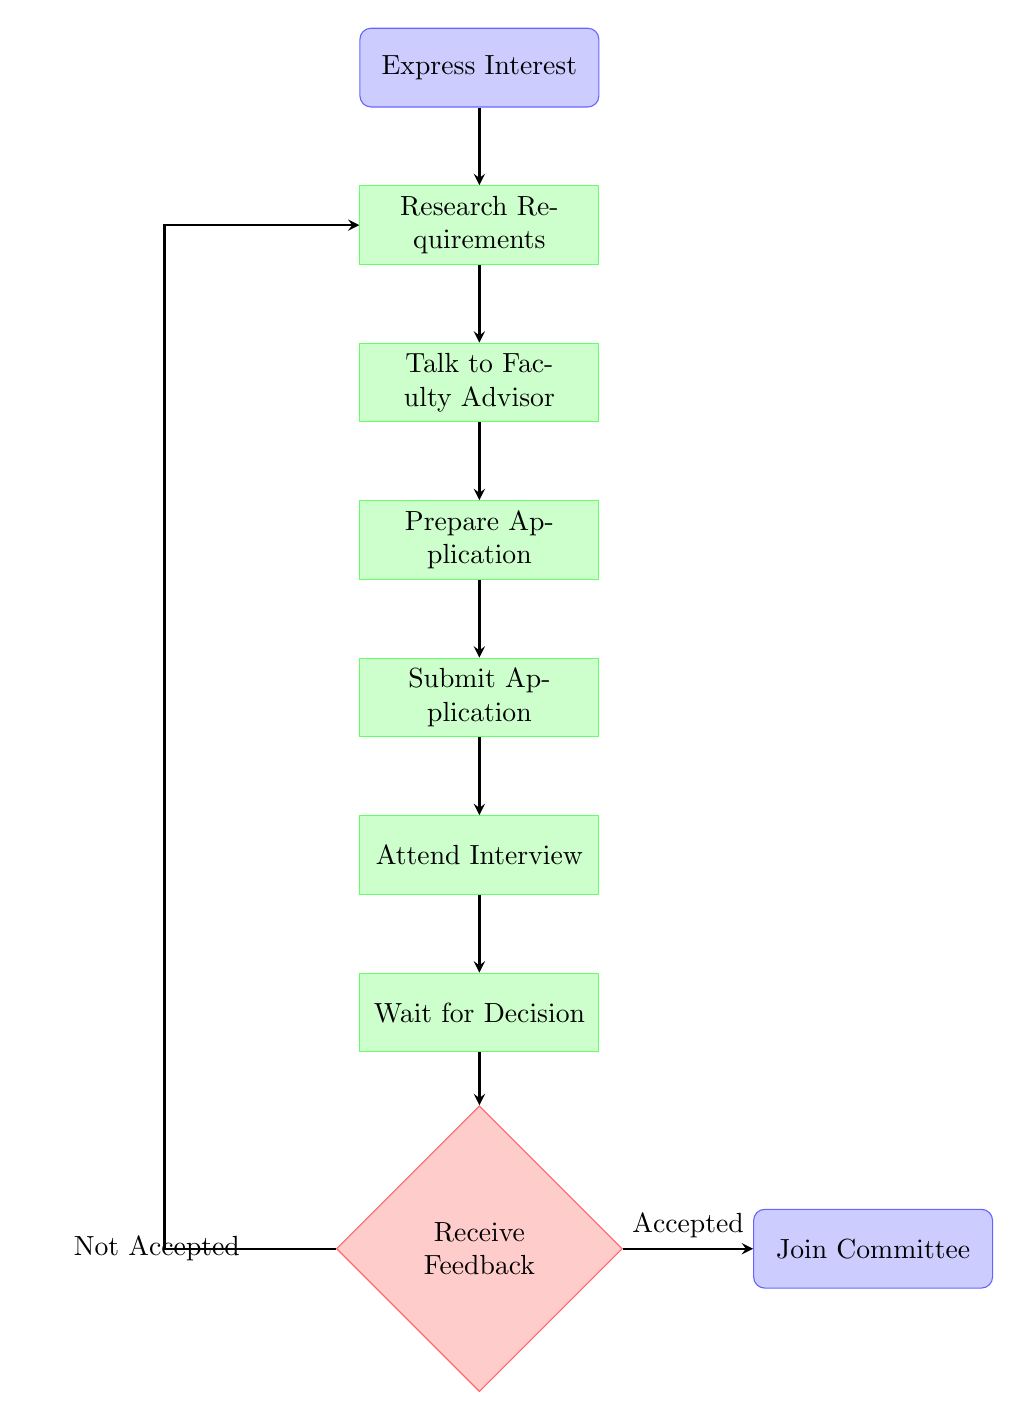What is the first step in joining the School Clubs Committee? The diagram begins with the node labeled "Express Interest," indicating that the first step is to determine your interest in joining the committee.
Answer: Express Interest How many main process nodes are there in the flow chart? The flow chart consists of seven main process nodes: "Express Interest," "Research Requirements," "Talk to Faculty Advisor," "Prepare Application," "Submit Application," "Attend Interview," and "Wait for Decision." Counting these nodes gives a total of seven.
Answer: 7 What happens after you attend the interview? Following the "Attend Interview" node, the next node is "Wait for Decision," indicating that after the interview, one must wait for the committee to make a decision regarding the application.
Answer: Wait for Decision If you receive feedback that you are not accepted, where do you go next? According to the diagram, if one receives feedback indicating not accepted, the flow directs back to "Research Requirements," suggesting that the candidate should look into the requirements again.
Answer: Research Requirements What is the final outcome if your application is accepted? The concluding step for an accepted application is represented by the node "Join Committee," meaning that if you are accepted, you will become an active member of the committee.
Answer: Join Committee What node comes immediately after "Prepare Application"? The node directly following "Prepare Application" is "Submit Application," indicating that the next action is to turn in the completed application.
Answer: Submit Application Describe the relationship between "Wait for Decision" and "Receive Feedback." "Wait for Decision" leads to "Receive Feedback," indicating that after waiting for a decision, you will receive some form of communication regarding your application status.
Answer: Receive Feedback What action should you take after deciding to express interest? After expressing interest, the next step is to "Research Requirements," suggesting that one should gather information about the qualifications needed to join the committee.
Answer: Research Requirements What can be inferred if you don't get accepted after the feedback? If not accepted, the flow indicates returning to "Research Requirements," implying that there are areas needing improvement or adjustments to enhance your chances of acceptance in the future.
Answer: Research Requirements 